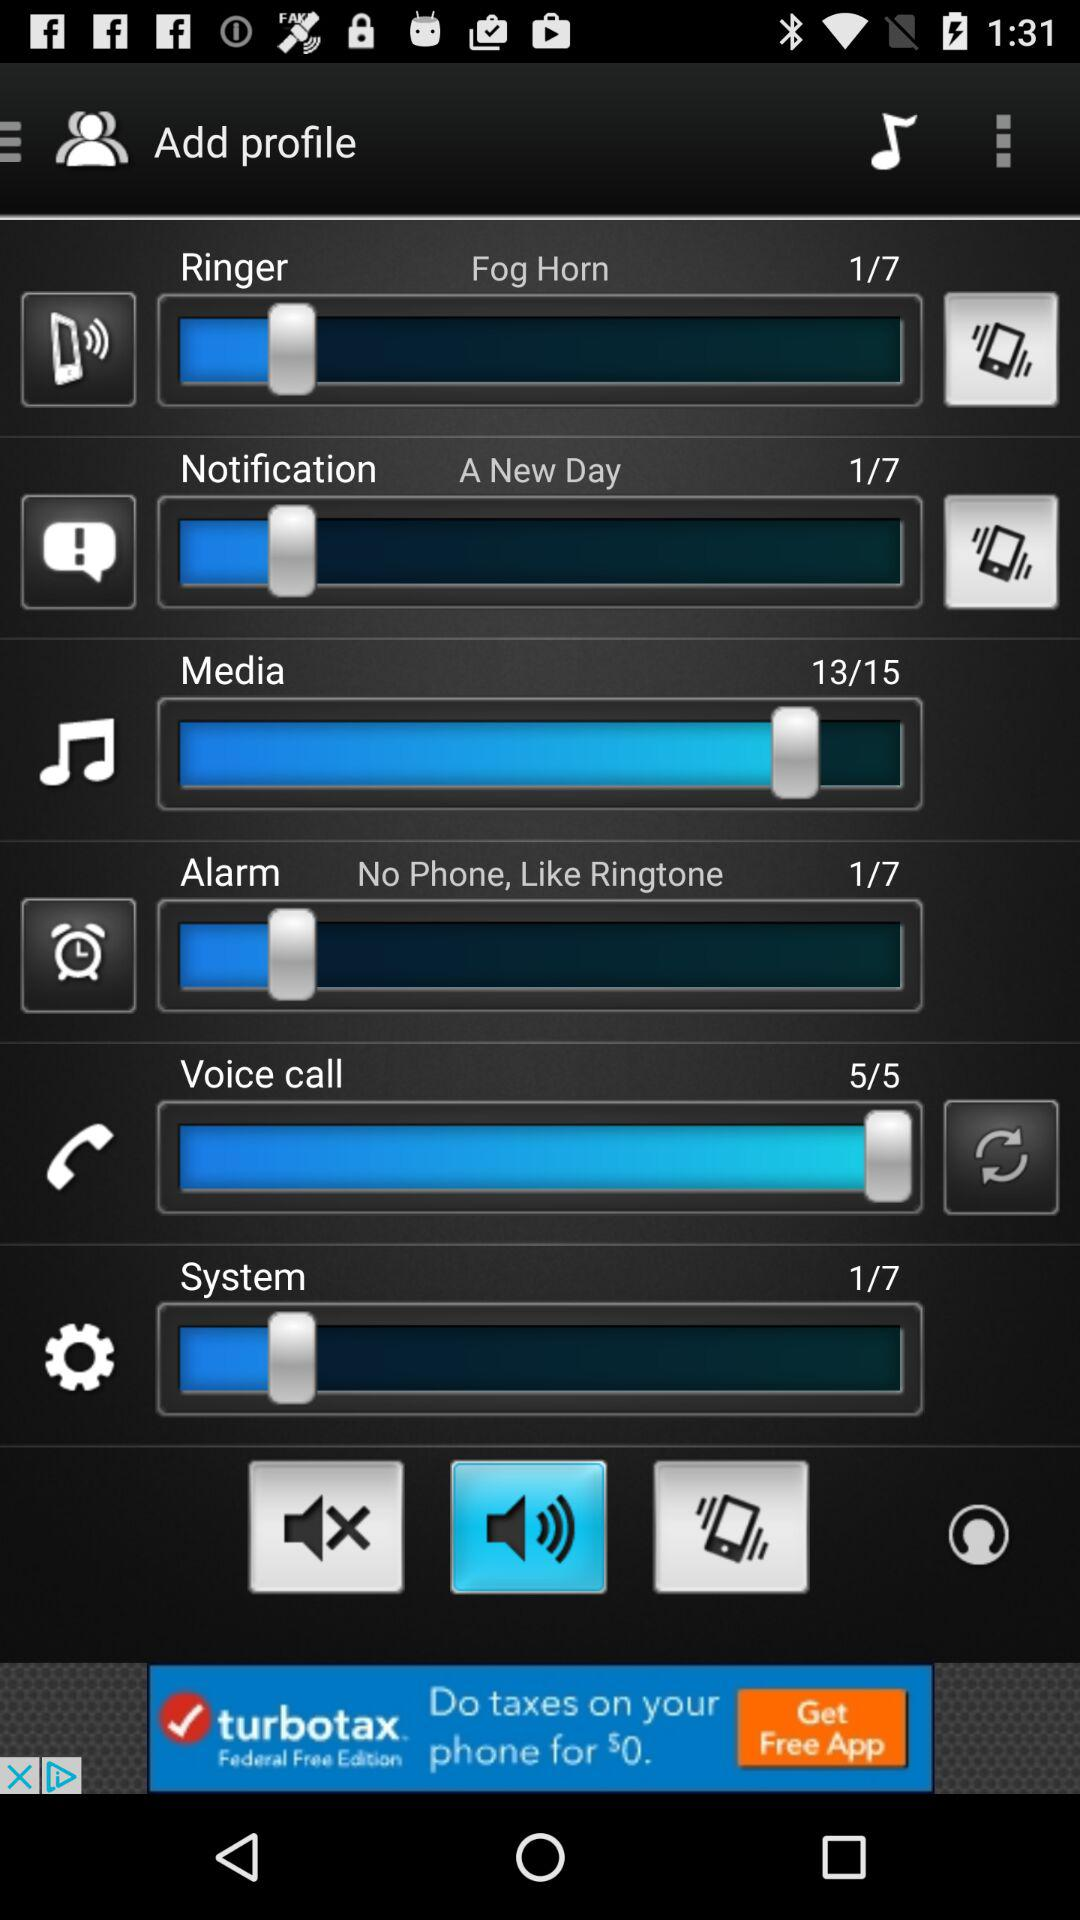What is the alarm volume level? The alarm volume level is 1. 